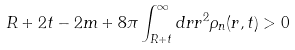<formula> <loc_0><loc_0><loc_500><loc_500>R + 2 t - 2 m + 8 \pi \int _ { R + t } ^ { \infty } d r r ^ { 2 } \rho _ { n } ( r , t ) > 0</formula> 